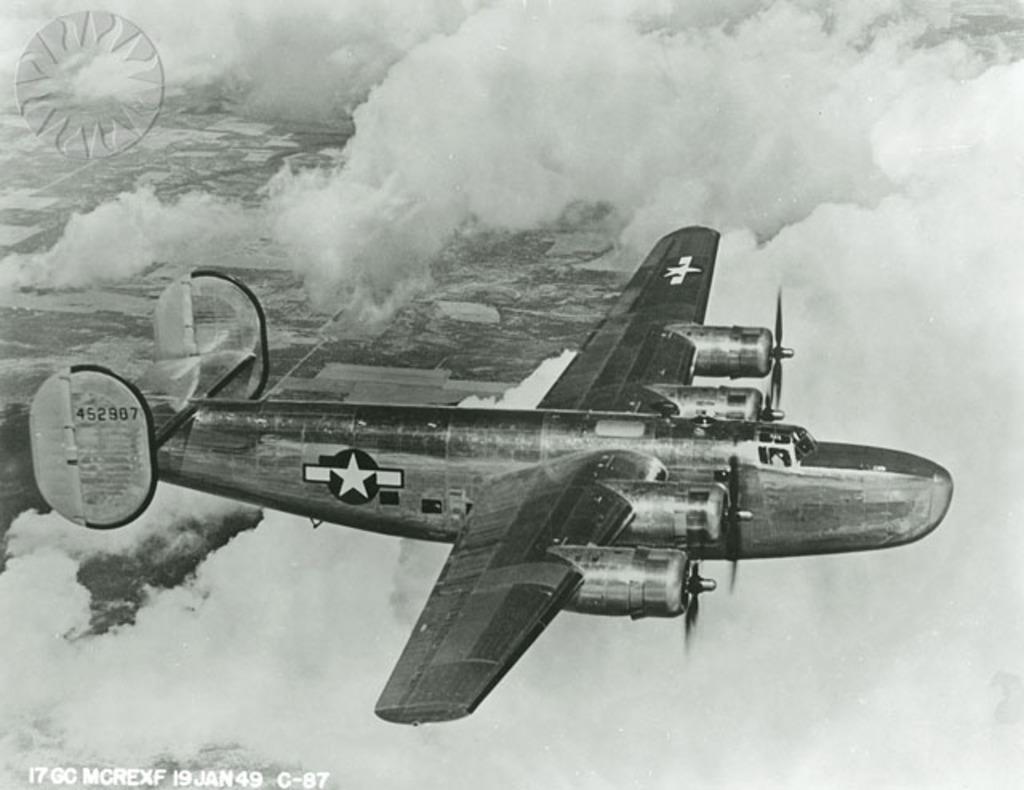What year was this photograph taken?
Give a very brief answer. 1949. What is the model of this aircraft?
Provide a succinct answer. 452907. 